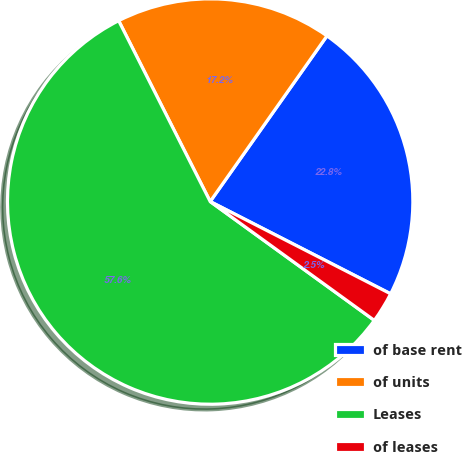Convert chart to OTSL. <chart><loc_0><loc_0><loc_500><loc_500><pie_chart><fcel>of base rent<fcel>of units<fcel>Leases<fcel>of leases<nl><fcel>22.75%<fcel>17.23%<fcel>57.57%<fcel>2.45%<nl></chart> 